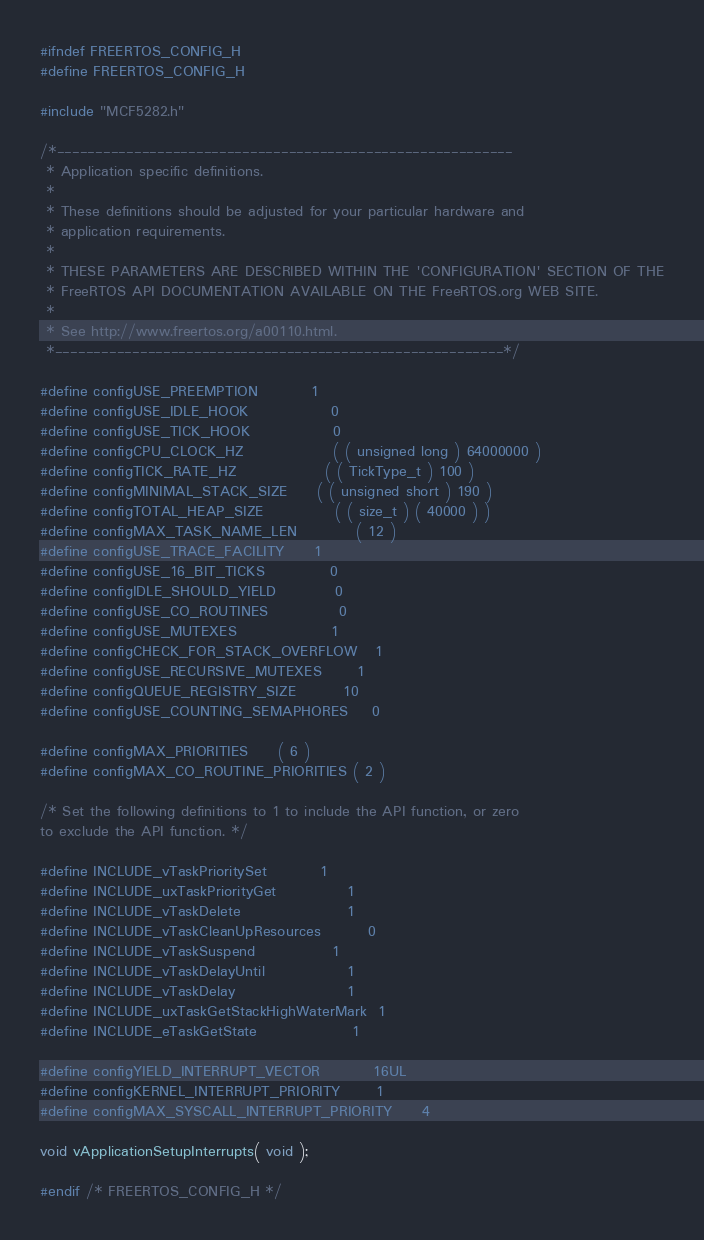Convert code to text. <code><loc_0><loc_0><loc_500><loc_500><_C_>#ifndef FREERTOS_CONFIG_H
#define FREERTOS_CONFIG_H

#include "MCF5282.h"

/*-----------------------------------------------------------
 * Application specific definitions.
 *
 * These definitions should be adjusted for your particular hardware and
 * application requirements.
 *
 * THESE PARAMETERS ARE DESCRIBED WITHIN THE 'CONFIGURATION' SECTION OF THE
 * FreeRTOS API DOCUMENTATION AVAILABLE ON THE FreeRTOS.org WEB SITE. 
 *
 * See http://www.freertos.org/a00110.html.
 *----------------------------------------------------------*/

#define configUSE_PREEMPTION			1
#define configUSE_IDLE_HOOK				0
#define configUSE_TICK_HOOK				0
#define configCPU_CLOCK_HZ				( ( unsigned long ) 64000000 )
#define configTICK_RATE_HZ				( ( TickType_t ) 100 )
#define configMINIMAL_STACK_SIZE		( ( unsigned short ) 190 )
#define configTOTAL_HEAP_SIZE			( ( size_t ) ( 40000 ) )
#define configMAX_TASK_NAME_LEN			( 12 )
#define configUSE_TRACE_FACILITY		1
#define configUSE_16_BIT_TICKS			0
#define configIDLE_SHOULD_YIELD			0
#define configUSE_CO_ROUTINES 			0
#define configUSE_MUTEXES				1
#define configCHECK_FOR_STACK_OVERFLOW	1
#define configUSE_RECURSIVE_MUTEXES		1
#define configQUEUE_REGISTRY_SIZE		10
#define configUSE_COUNTING_SEMAPHORES	0

#define configMAX_PRIORITIES		( 6 )
#define configMAX_CO_ROUTINE_PRIORITIES ( 2 )

/* Set the following definitions to 1 to include the API function, or zero
to exclude the API function. */

#define INCLUDE_vTaskPrioritySet			1
#define INCLUDE_uxTaskPriorityGet			1
#define INCLUDE_vTaskDelete					1
#define INCLUDE_vTaskCleanUpResources		0
#define INCLUDE_vTaskSuspend				1
#define INCLUDE_vTaskDelayUntil				1
#define INCLUDE_vTaskDelay					1
#define INCLUDE_uxTaskGetStackHighWaterMark	1
#define INCLUDE_eTaskGetState				1

#define configYIELD_INTERRUPT_VECTOR			16UL
#define configKERNEL_INTERRUPT_PRIORITY 		1
#define configMAX_SYSCALL_INTERRUPT_PRIORITY 	4

void vApplicationSetupInterrupts( void );

#endif /* FREERTOS_CONFIG_H */
</code> 